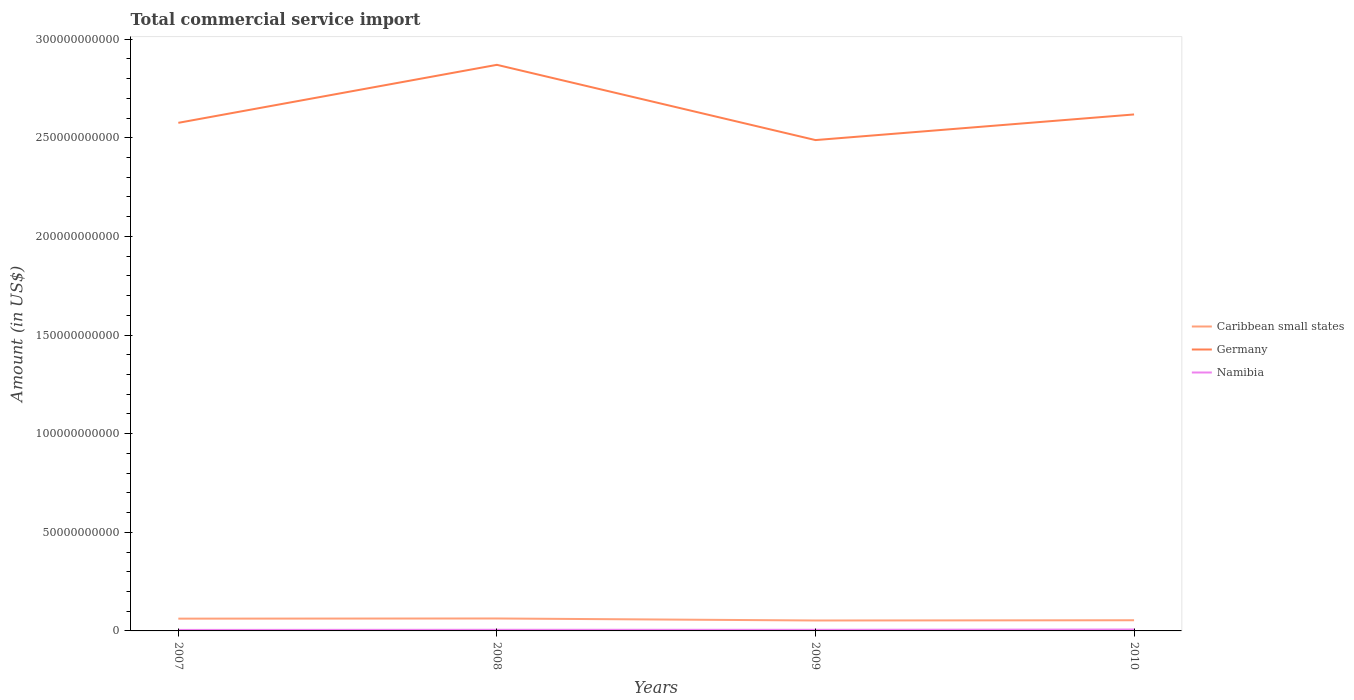Across all years, what is the maximum total commercial service import in Germany?
Provide a short and direct response. 2.49e+11. What is the total total commercial service import in Caribbean small states in the graph?
Provide a succinct answer. -8.18e+07. What is the difference between the highest and the second highest total commercial service import in Germany?
Provide a short and direct response. 3.81e+1. Is the total commercial service import in Caribbean small states strictly greater than the total commercial service import in Germany over the years?
Keep it short and to the point. Yes. How many years are there in the graph?
Provide a succinct answer. 4. What is the difference between two consecutive major ticks on the Y-axis?
Ensure brevity in your answer.  5.00e+1. Are the values on the major ticks of Y-axis written in scientific E-notation?
Your answer should be very brief. No. Does the graph contain grids?
Give a very brief answer. No. How many legend labels are there?
Your answer should be compact. 3. How are the legend labels stacked?
Offer a very short reply. Vertical. What is the title of the graph?
Your response must be concise. Total commercial service import. Does "Vanuatu" appear as one of the legend labels in the graph?
Ensure brevity in your answer.  No. What is the label or title of the X-axis?
Offer a very short reply. Years. What is the Amount (in US$) of Caribbean small states in 2007?
Offer a terse response. 6.23e+09. What is the Amount (in US$) of Germany in 2007?
Provide a short and direct response. 2.58e+11. What is the Amount (in US$) of Namibia in 2007?
Your answer should be compact. 5.04e+08. What is the Amount (in US$) of Caribbean small states in 2008?
Give a very brief answer. 6.31e+09. What is the Amount (in US$) of Germany in 2008?
Your response must be concise. 2.87e+11. What is the Amount (in US$) of Namibia in 2008?
Provide a succinct answer. 5.78e+08. What is the Amount (in US$) of Caribbean small states in 2009?
Your answer should be compact. 5.29e+09. What is the Amount (in US$) of Germany in 2009?
Your answer should be very brief. 2.49e+11. What is the Amount (in US$) in Namibia in 2009?
Ensure brevity in your answer.  5.69e+08. What is the Amount (in US$) of Caribbean small states in 2010?
Offer a terse response. 5.41e+09. What is the Amount (in US$) of Germany in 2010?
Provide a short and direct response. 2.62e+11. What is the Amount (in US$) of Namibia in 2010?
Give a very brief answer. 7.23e+08. Across all years, what is the maximum Amount (in US$) of Caribbean small states?
Your answer should be compact. 6.31e+09. Across all years, what is the maximum Amount (in US$) in Germany?
Keep it short and to the point. 2.87e+11. Across all years, what is the maximum Amount (in US$) in Namibia?
Give a very brief answer. 7.23e+08. Across all years, what is the minimum Amount (in US$) of Caribbean small states?
Provide a short and direct response. 5.29e+09. Across all years, what is the minimum Amount (in US$) of Germany?
Give a very brief answer. 2.49e+11. Across all years, what is the minimum Amount (in US$) of Namibia?
Offer a very short reply. 5.04e+08. What is the total Amount (in US$) in Caribbean small states in the graph?
Make the answer very short. 2.32e+1. What is the total Amount (in US$) in Germany in the graph?
Keep it short and to the point. 1.06e+12. What is the total Amount (in US$) in Namibia in the graph?
Offer a terse response. 2.37e+09. What is the difference between the Amount (in US$) of Caribbean small states in 2007 and that in 2008?
Provide a succinct answer. -8.18e+07. What is the difference between the Amount (in US$) in Germany in 2007 and that in 2008?
Provide a succinct answer. -2.94e+1. What is the difference between the Amount (in US$) of Namibia in 2007 and that in 2008?
Keep it short and to the point. -7.41e+07. What is the difference between the Amount (in US$) in Caribbean small states in 2007 and that in 2009?
Your answer should be compact. 9.32e+08. What is the difference between the Amount (in US$) in Germany in 2007 and that in 2009?
Make the answer very short. 8.75e+09. What is the difference between the Amount (in US$) in Namibia in 2007 and that in 2009?
Provide a succinct answer. -6.54e+07. What is the difference between the Amount (in US$) of Caribbean small states in 2007 and that in 2010?
Keep it short and to the point. 8.21e+08. What is the difference between the Amount (in US$) in Germany in 2007 and that in 2010?
Your answer should be very brief. -4.25e+09. What is the difference between the Amount (in US$) of Namibia in 2007 and that in 2010?
Keep it short and to the point. -2.19e+08. What is the difference between the Amount (in US$) of Caribbean small states in 2008 and that in 2009?
Give a very brief answer. 1.01e+09. What is the difference between the Amount (in US$) of Germany in 2008 and that in 2009?
Provide a short and direct response. 3.81e+1. What is the difference between the Amount (in US$) in Namibia in 2008 and that in 2009?
Offer a terse response. 8.69e+06. What is the difference between the Amount (in US$) of Caribbean small states in 2008 and that in 2010?
Offer a terse response. 9.02e+08. What is the difference between the Amount (in US$) of Germany in 2008 and that in 2010?
Provide a short and direct response. 2.52e+1. What is the difference between the Amount (in US$) of Namibia in 2008 and that in 2010?
Your response must be concise. -1.45e+08. What is the difference between the Amount (in US$) in Caribbean small states in 2009 and that in 2010?
Make the answer very short. -1.12e+08. What is the difference between the Amount (in US$) of Germany in 2009 and that in 2010?
Provide a short and direct response. -1.30e+1. What is the difference between the Amount (in US$) of Namibia in 2009 and that in 2010?
Provide a succinct answer. -1.53e+08. What is the difference between the Amount (in US$) of Caribbean small states in 2007 and the Amount (in US$) of Germany in 2008?
Your answer should be very brief. -2.81e+11. What is the difference between the Amount (in US$) in Caribbean small states in 2007 and the Amount (in US$) in Namibia in 2008?
Your answer should be very brief. 5.65e+09. What is the difference between the Amount (in US$) of Germany in 2007 and the Amount (in US$) of Namibia in 2008?
Your response must be concise. 2.57e+11. What is the difference between the Amount (in US$) in Caribbean small states in 2007 and the Amount (in US$) in Germany in 2009?
Your answer should be compact. -2.43e+11. What is the difference between the Amount (in US$) in Caribbean small states in 2007 and the Amount (in US$) in Namibia in 2009?
Provide a short and direct response. 5.66e+09. What is the difference between the Amount (in US$) of Germany in 2007 and the Amount (in US$) of Namibia in 2009?
Your response must be concise. 2.57e+11. What is the difference between the Amount (in US$) in Caribbean small states in 2007 and the Amount (in US$) in Germany in 2010?
Give a very brief answer. -2.56e+11. What is the difference between the Amount (in US$) of Caribbean small states in 2007 and the Amount (in US$) of Namibia in 2010?
Make the answer very short. 5.50e+09. What is the difference between the Amount (in US$) in Germany in 2007 and the Amount (in US$) in Namibia in 2010?
Your answer should be very brief. 2.57e+11. What is the difference between the Amount (in US$) in Caribbean small states in 2008 and the Amount (in US$) in Germany in 2009?
Give a very brief answer. -2.43e+11. What is the difference between the Amount (in US$) of Caribbean small states in 2008 and the Amount (in US$) of Namibia in 2009?
Keep it short and to the point. 5.74e+09. What is the difference between the Amount (in US$) in Germany in 2008 and the Amount (in US$) in Namibia in 2009?
Your answer should be very brief. 2.86e+11. What is the difference between the Amount (in US$) of Caribbean small states in 2008 and the Amount (in US$) of Germany in 2010?
Provide a short and direct response. -2.56e+11. What is the difference between the Amount (in US$) in Caribbean small states in 2008 and the Amount (in US$) in Namibia in 2010?
Your answer should be very brief. 5.59e+09. What is the difference between the Amount (in US$) of Germany in 2008 and the Amount (in US$) of Namibia in 2010?
Make the answer very short. 2.86e+11. What is the difference between the Amount (in US$) in Caribbean small states in 2009 and the Amount (in US$) in Germany in 2010?
Keep it short and to the point. -2.57e+11. What is the difference between the Amount (in US$) of Caribbean small states in 2009 and the Amount (in US$) of Namibia in 2010?
Offer a terse response. 4.57e+09. What is the difference between the Amount (in US$) of Germany in 2009 and the Amount (in US$) of Namibia in 2010?
Your response must be concise. 2.48e+11. What is the average Amount (in US$) of Caribbean small states per year?
Give a very brief answer. 5.81e+09. What is the average Amount (in US$) of Germany per year?
Provide a short and direct response. 2.64e+11. What is the average Amount (in US$) of Namibia per year?
Your response must be concise. 5.93e+08. In the year 2007, what is the difference between the Amount (in US$) of Caribbean small states and Amount (in US$) of Germany?
Provide a short and direct response. -2.51e+11. In the year 2007, what is the difference between the Amount (in US$) in Caribbean small states and Amount (in US$) in Namibia?
Offer a terse response. 5.72e+09. In the year 2007, what is the difference between the Amount (in US$) in Germany and Amount (in US$) in Namibia?
Offer a terse response. 2.57e+11. In the year 2008, what is the difference between the Amount (in US$) of Caribbean small states and Amount (in US$) of Germany?
Your response must be concise. -2.81e+11. In the year 2008, what is the difference between the Amount (in US$) in Caribbean small states and Amount (in US$) in Namibia?
Give a very brief answer. 5.73e+09. In the year 2008, what is the difference between the Amount (in US$) of Germany and Amount (in US$) of Namibia?
Give a very brief answer. 2.86e+11. In the year 2009, what is the difference between the Amount (in US$) in Caribbean small states and Amount (in US$) in Germany?
Offer a very short reply. -2.44e+11. In the year 2009, what is the difference between the Amount (in US$) in Caribbean small states and Amount (in US$) in Namibia?
Provide a short and direct response. 4.72e+09. In the year 2009, what is the difference between the Amount (in US$) of Germany and Amount (in US$) of Namibia?
Your answer should be very brief. 2.48e+11. In the year 2010, what is the difference between the Amount (in US$) of Caribbean small states and Amount (in US$) of Germany?
Keep it short and to the point. -2.56e+11. In the year 2010, what is the difference between the Amount (in US$) of Caribbean small states and Amount (in US$) of Namibia?
Offer a very short reply. 4.68e+09. In the year 2010, what is the difference between the Amount (in US$) in Germany and Amount (in US$) in Namibia?
Your answer should be very brief. 2.61e+11. What is the ratio of the Amount (in US$) in Germany in 2007 to that in 2008?
Ensure brevity in your answer.  0.9. What is the ratio of the Amount (in US$) of Namibia in 2007 to that in 2008?
Make the answer very short. 0.87. What is the ratio of the Amount (in US$) of Caribbean small states in 2007 to that in 2009?
Give a very brief answer. 1.18. What is the ratio of the Amount (in US$) in Germany in 2007 to that in 2009?
Keep it short and to the point. 1.04. What is the ratio of the Amount (in US$) of Namibia in 2007 to that in 2009?
Offer a very short reply. 0.89. What is the ratio of the Amount (in US$) in Caribbean small states in 2007 to that in 2010?
Your answer should be compact. 1.15. What is the ratio of the Amount (in US$) of Germany in 2007 to that in 2010?
Offer a terse response. 0.98. What is the ratio of the Amount (in US$) in Namibia in 2007 to that in 2010?
Keep it short and to the point. 0.7. What is the ratio of the Amount (in US$) in Caribbean small states in 2008 to that in 2009?
Keep it short and to the point. 1.19. What is the ratio of the Amount (in US$) of Germany in 2008 to that in 2009?
Provide a short and direct response. 1.15. What is the ratio of the Amount (in US$) of Namibia in 2008 to that in 2009?
Your answer should be compact. 1.02. What is the ratio of the Amount (in US$) in Caribbean small states in 2008 to that in 2010?
Your answer should be very brief. 1.17. What is the ratio of the Amount (in US$) in Germany in 2008 to that in 2010?
Keep it short and to the point. 1.1. What is the ratio of the Amount (in US$) of Namibia in 2008 to that in 2010?
Offer a very short reply. 0.8. What is the ratio of the Amount (in US$) of Caribbean small states in 2009 to that in 2010?
Give a very brief answer. 0.98. What is the ratio of the Amount (in US$) of Germany in 2009 to that in 2010?
Your answer should be compact. 0.95. What is the ratio of the Amount (in US$) of Namibia in 2009 to that in 2010?
Your answer should be compact. 0.79. What is the difference between the highest and the second highest Amount (in US$) of Caribbean small states?
Offer a terse response. 8.18e+07. What is the difference between the highest and the second highest Amount (in US$) of Germany?
Keep it short and to the point. 2.52e+1. What is the difference between the highest and the second highest Amount (in US$) of Namibia?
Provide a short and direct response. 1.45e+08. What is the difference between the highest and the lowest Amount (in US$) of Caribbean small states?
Offer a terse response. 1.01e+09. What is the difference between the highest and the lowest Amount (in US$) of Germany?
Your answer should be compact. 3.81e+1. What is the difference between the highest and the lowest Amount (in US$) in Namibia?
Ensure brevity in your answer.  2.19e+08. 